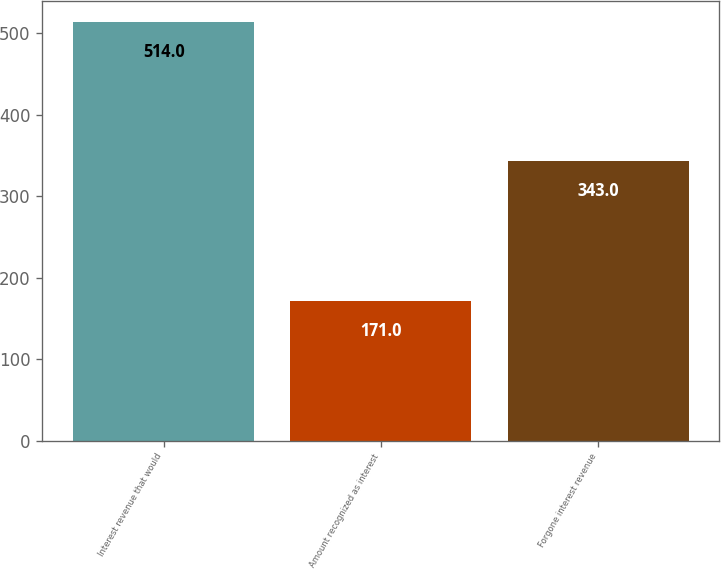Convert chart. <chart><loc_0><loc_0><loc_500><loc_500><bar_chart><fcel>Interest revenue that would<fcel>Amount recognized as interest<fcel>Forgone interest revenue<nl><fcel>514<fcel>171<fcel>343<nl></chart> 